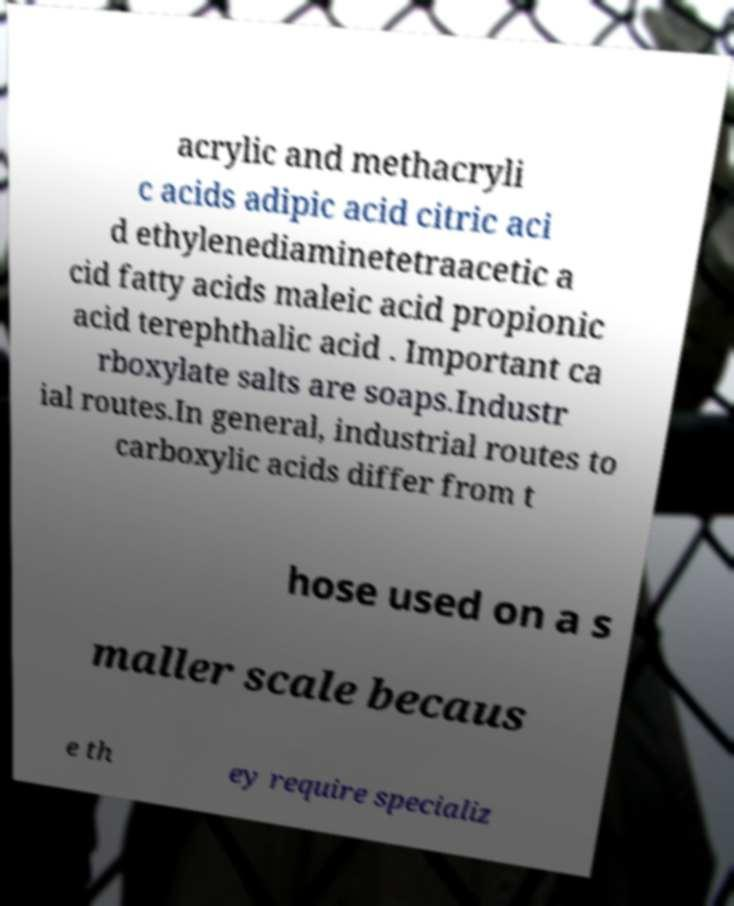Could you extract and type out the text from this image? acrylic and methacryli c acids adipic acid citric aci d ethylenediaminetetraacetic a cid fatty acids maleic acid propionic acid terephthalic acid . Important ca rboxylate salts are soaps.Industr ial routes.In general, industrial routes to carboxylic acids differ from t hose used on a s maller scale becaus e th ey require specializ 